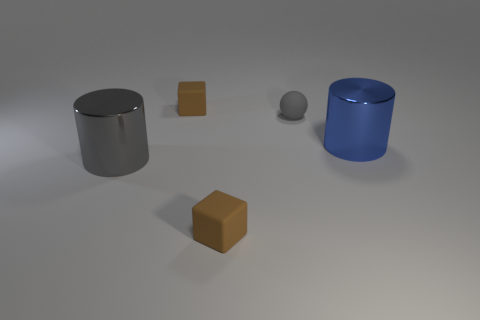Add 2 brown matte blocks. How many objects exist? 7 Subtract all large things. Subtract all brown rubber blocks. How many objects are left? 1 Add 2 shiny cylinders. How many shiny cylinders are left? 4 Add 3 large blue metallic objects. How many large blue metallic objects exist? 4 Subtract 0 blue cubes. How many objects are left? 5 Subtract all cubes. How many objects are left? 3 Subtract all purple cubes. Subtract all red spheres. How many cubes are left? 2 